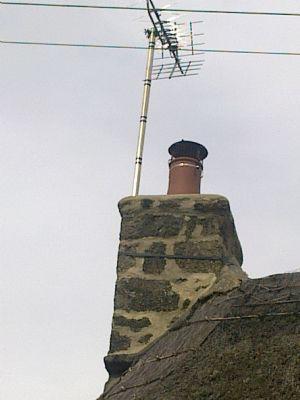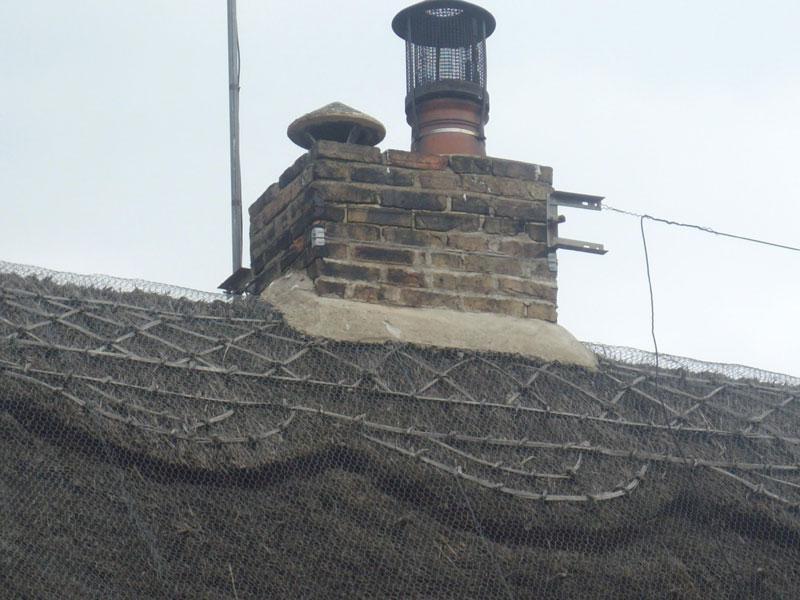The first image is the image on the left, the second image is the image on the right. Considering the images on both sides, is "The left image shows a ladder leaning against a thatched roof, with the top of the ladder near a red brick chimney." valid? Answer yes or no. No. The first image is the image on the left, the second image is the image on the right. Given the left and right images, does the statement "In at least one image there is a silver ladder placed on the roof pointed toward the brick chimney." hold true? Answer yes or no. No. 